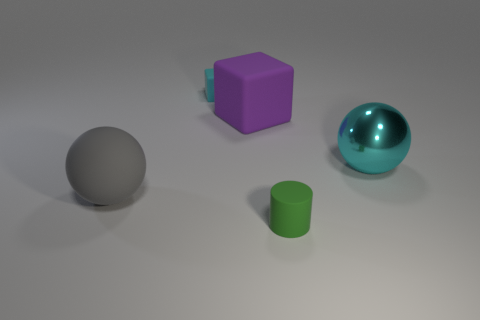There is a small matte thing that is the same color as the metallic ball; what is its shape?
Provide a short and direct response. Cube. Are there any other things that have the same material as the cyan sphere?
Your response must be concise. No. Is there anything else that is the same color as the shiny sphere?
Offer a terse response. Yes. Do the big sphere to the left of the green cylinder and the cyan object left of the rubber cylinder have the same material?
Offer a terse response. Yes. There is a thing that is behind the gray matte object and left of the large purple block; what material is it?
Give a very brief answer. Rubber. There is a purple thing; is it the same shape as the big matte object in front of the purple rubber block?
Offer a very short reply. No. There is a tiny thing that is behind the sphere that is left of the tiny rubber thing that is behind the tiny green matte object; what is it made of?
Offer a terse response. Rubber. How many other things are the same size as the gray rubber sphere?
Ensure brevity in your answer.  2. Do the large shiny object and the tiny rubber block have the same color?
Your response must be concise. Yes. There is a rubber object on the left side of the rubber block that is behind the purple matte cube; how many green cylinders are right of it?
Provide a succinct answer. 1. 